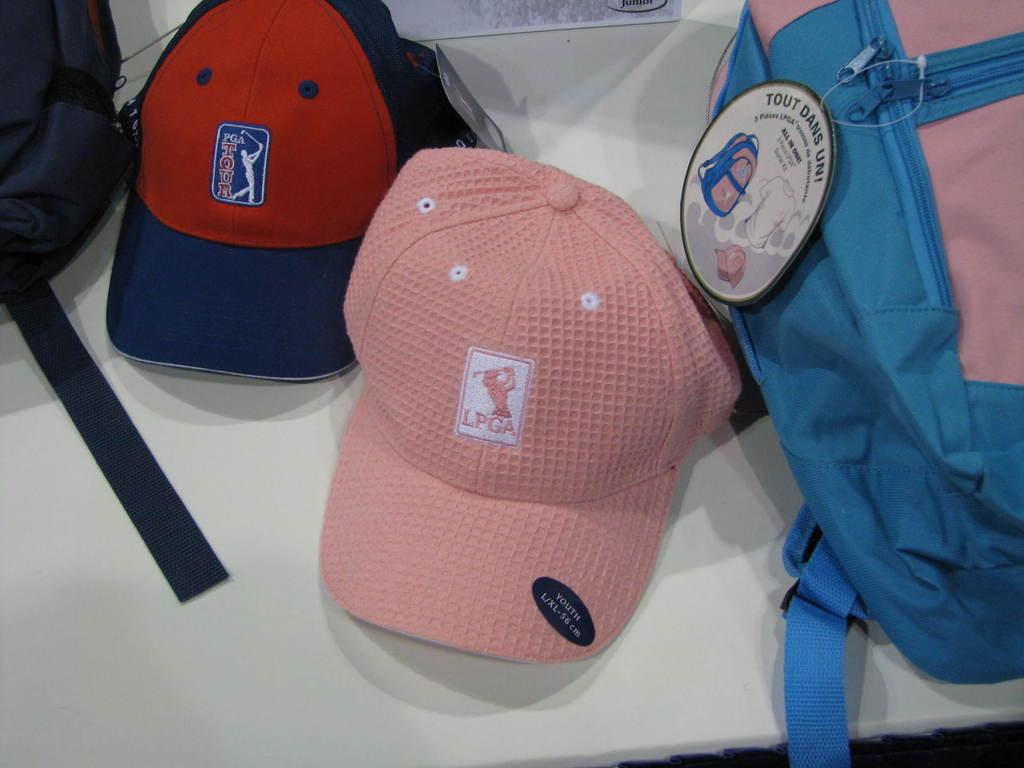<image>
Offer a succinct explanation of the picture presented. A pink hat with the LPGA logo has a black sticker on the brim. 